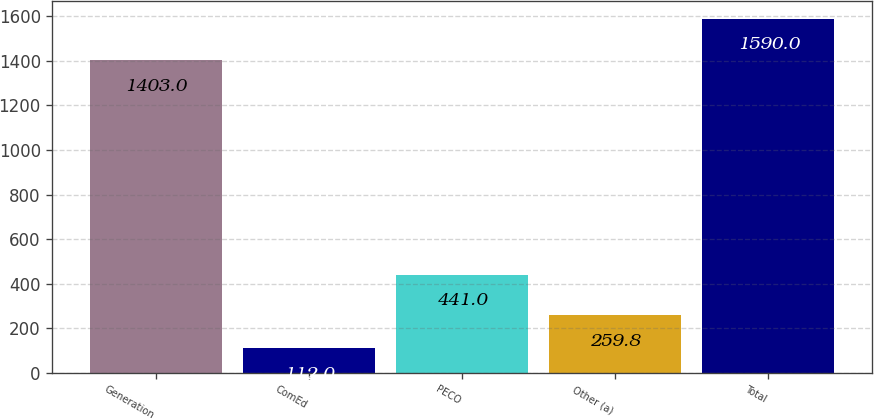Convert chart. <chart><loc_0><loc_0><loc_500><loc_500><bar_chart><fcel>Generation<fcel>ComEd<fcel>PECO<fcel>Other (a)<fcel>Total<nl><fcel>1403<fcel>112<fcel>441<fcel>259.8<fcel>1590<nl></chart> 